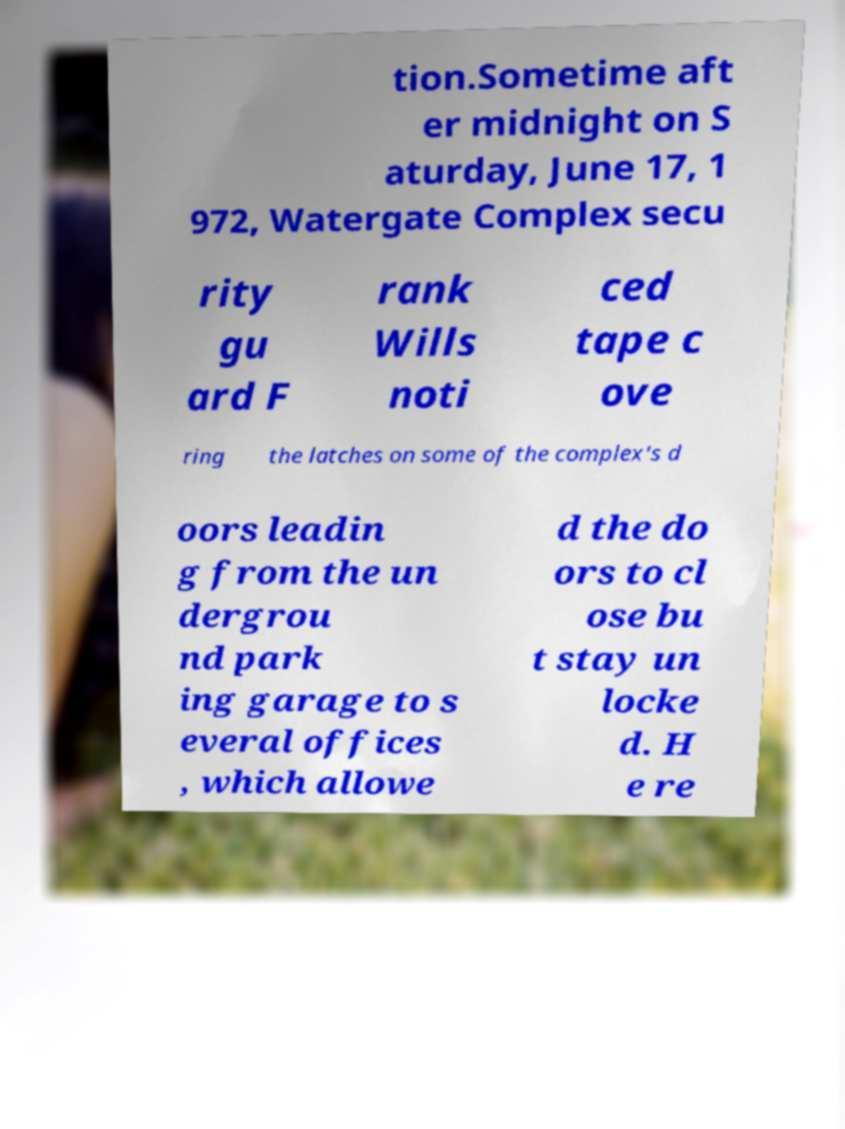For documentation purposes, I need the text within this image transcribed. Could you provide that? tion.Sometime aft er midnight on S aturday, June 17, 1 972, Watergate Complex secu rity gu ard F rank Wills noti ced tape c ove ring the latches on some of the complex's d oors leadin g from the un dergrou nd park ing garage to s everal offices , which allowe d the do ors to cl ose bu t stay un locke d. H e re 